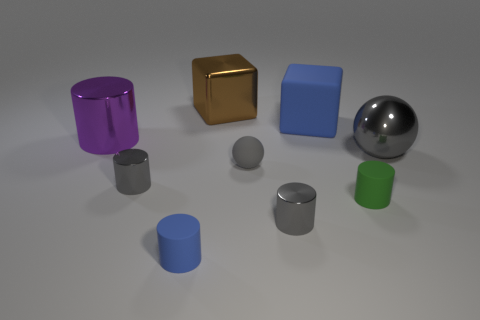Does the big blue thing have the same shape as the green thing? no 